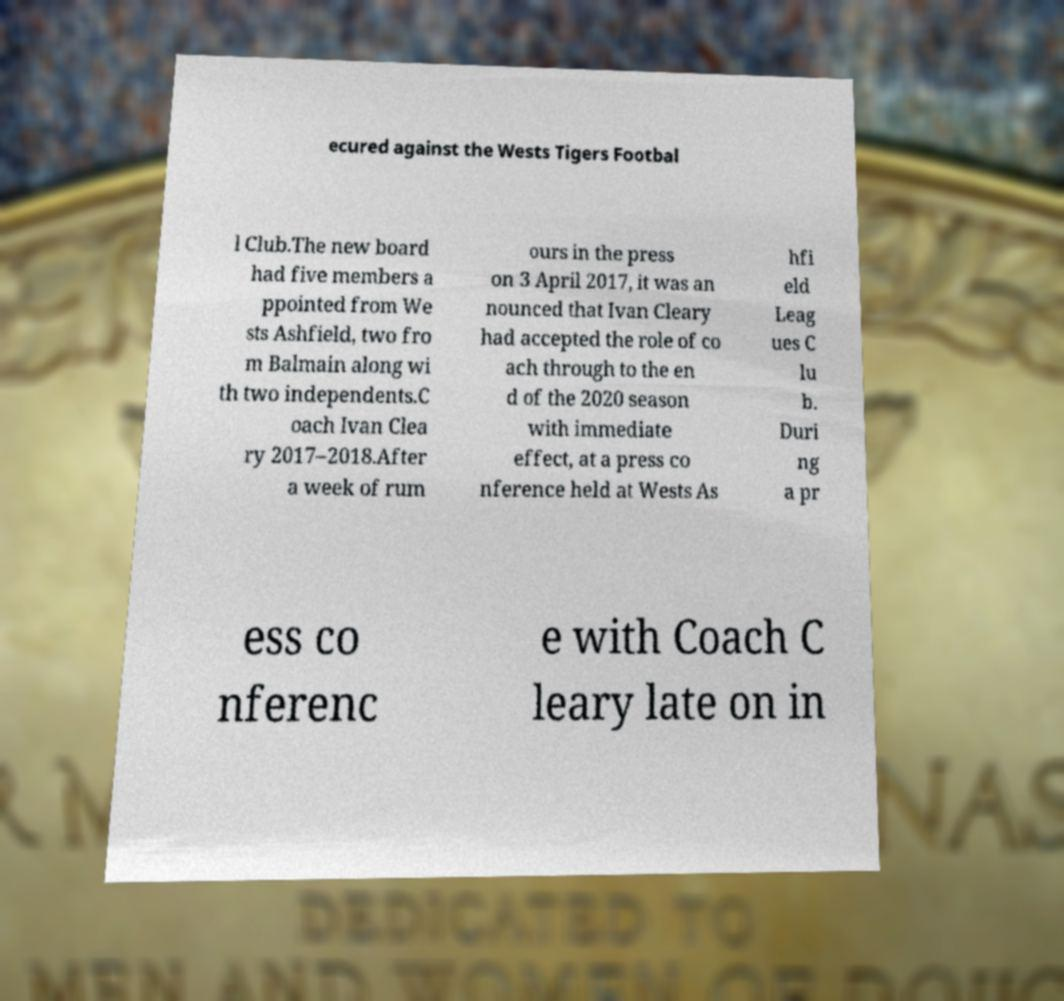I need the written content from this picture converted into text. Can you do that? ecured against the Wests Tigers Footbal l Club.The new board had five members a ppointed from We sts Ashfield, two fro m Balmain along wi th two independents.C oach Ivan Clea ry 2017–2018.After a week of rum ours in the press on 3 April 2017, it was an nounced that Ivan Cleary had accepted the role of co ach through to the en d of the 2020 season with immediate effect, at a press co nference held at Wests As hfi eld Leag ues C lu b. Duri ng a pr ess co nferenc e with Coach C leary late on in 